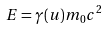<formula> <loc_0><loc_0><loc_500><loc_500>E = \gamma ( u ) m _ { 0 } c ^ { 2 }</formula> 